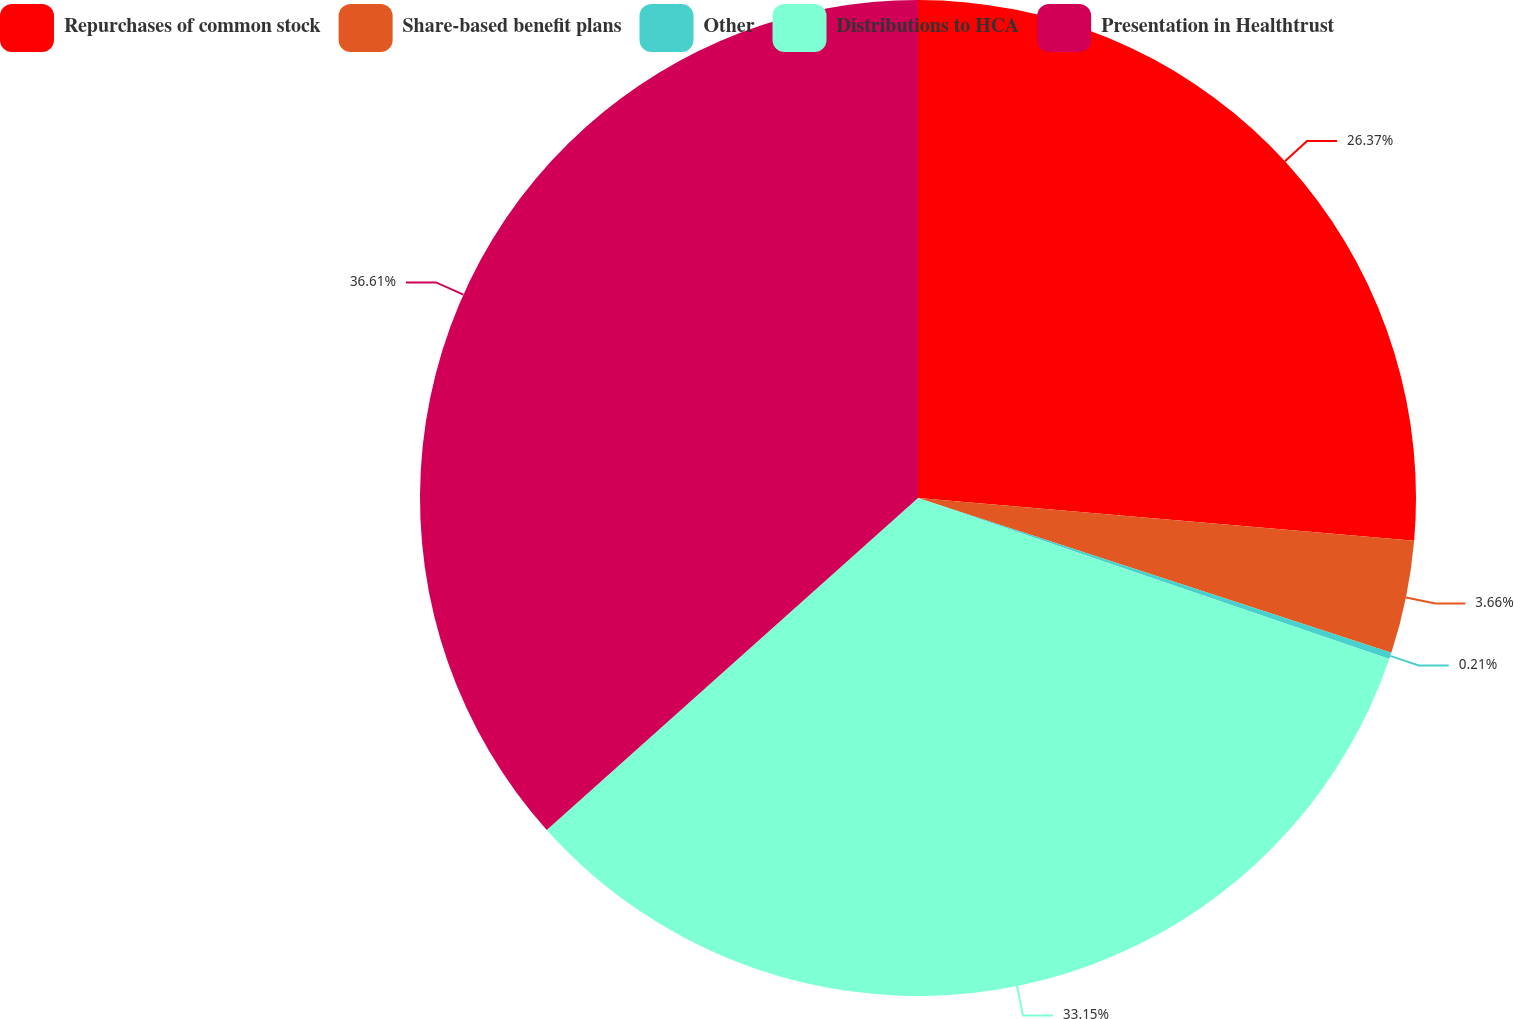Convert chart to OTSL. <chart><loc_0><loc_0><loc_500><loc_500><pie_chart><fcel>Repurchases of common stock<fcel>Share-based benefit plans<fcel>Other<fcel>Distributions to HCA<fcel>Presentation in Healthtrust<nl><fcel>26.37%<fcel>3.66%<fcel>0.21%<fcel>33.15%<fcel>36.61%<nl></chart> 